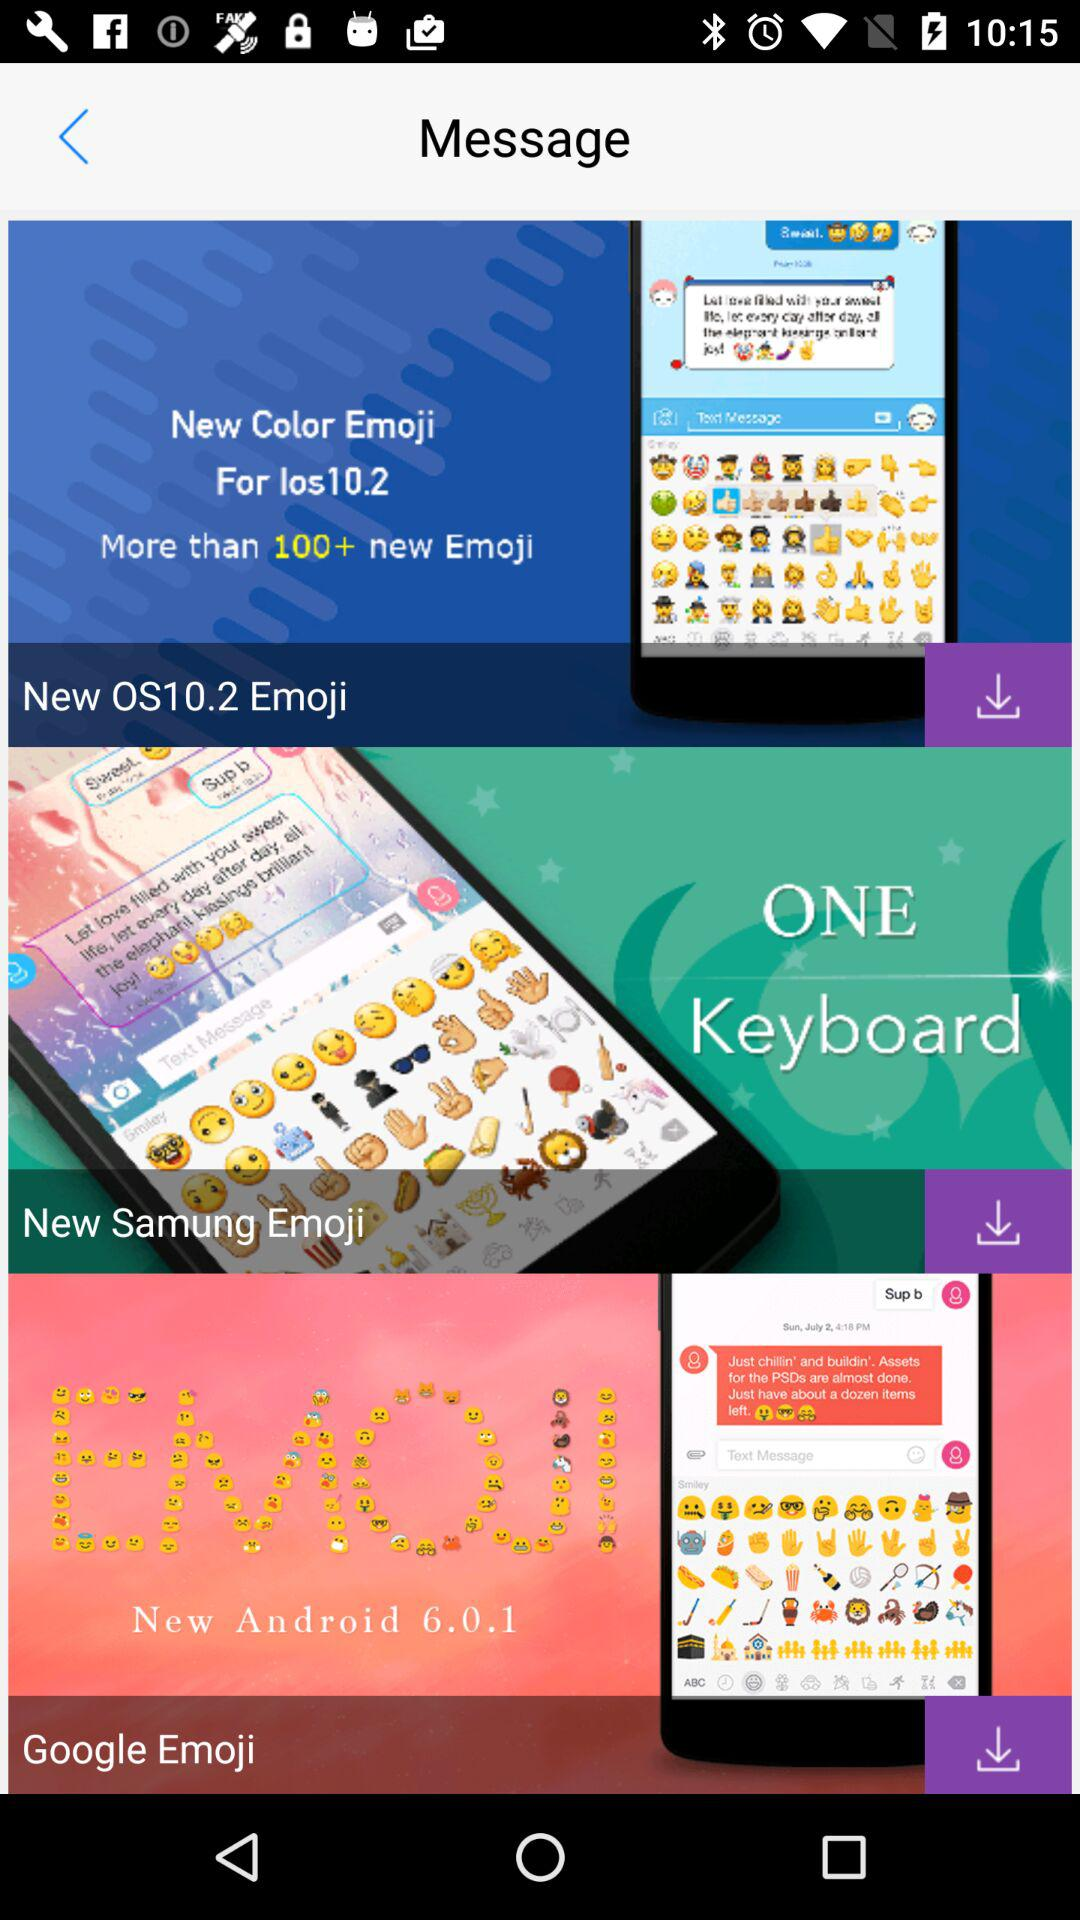How many emoji sets are there?
Answer the question using a single word or phrase. 3 